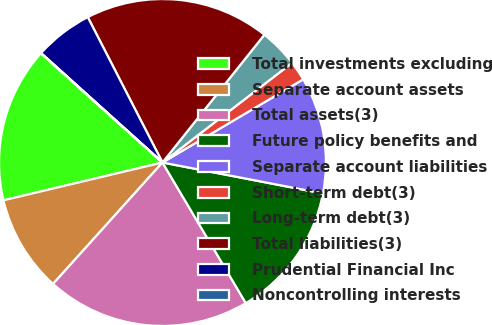Convert chart. <chart><loc_0><loc_0><loc_500><loc_500><pie_chart><fcel>Total investments excluding<fcel>Separate account assets<fcel>Total assets(3)<fcel>Future policy benefits and<fcel>Separate account liabilities<fcel>Short-term debt(3)<fcel>Long-term debt(3)<fcel>Total liabilities(3)<fcel>Prudential Financial Inc<fcel>Noncontrolling interests<nl><fcel>15.37%<fcel>9.61%<fcel>20.19%<fcel>13.45%<fcel>11.53%<fcel>1.94%<fcel>3.85%<fcel>18.27%<fcel>5.77%<fcel>0.02%<nl></chart> 